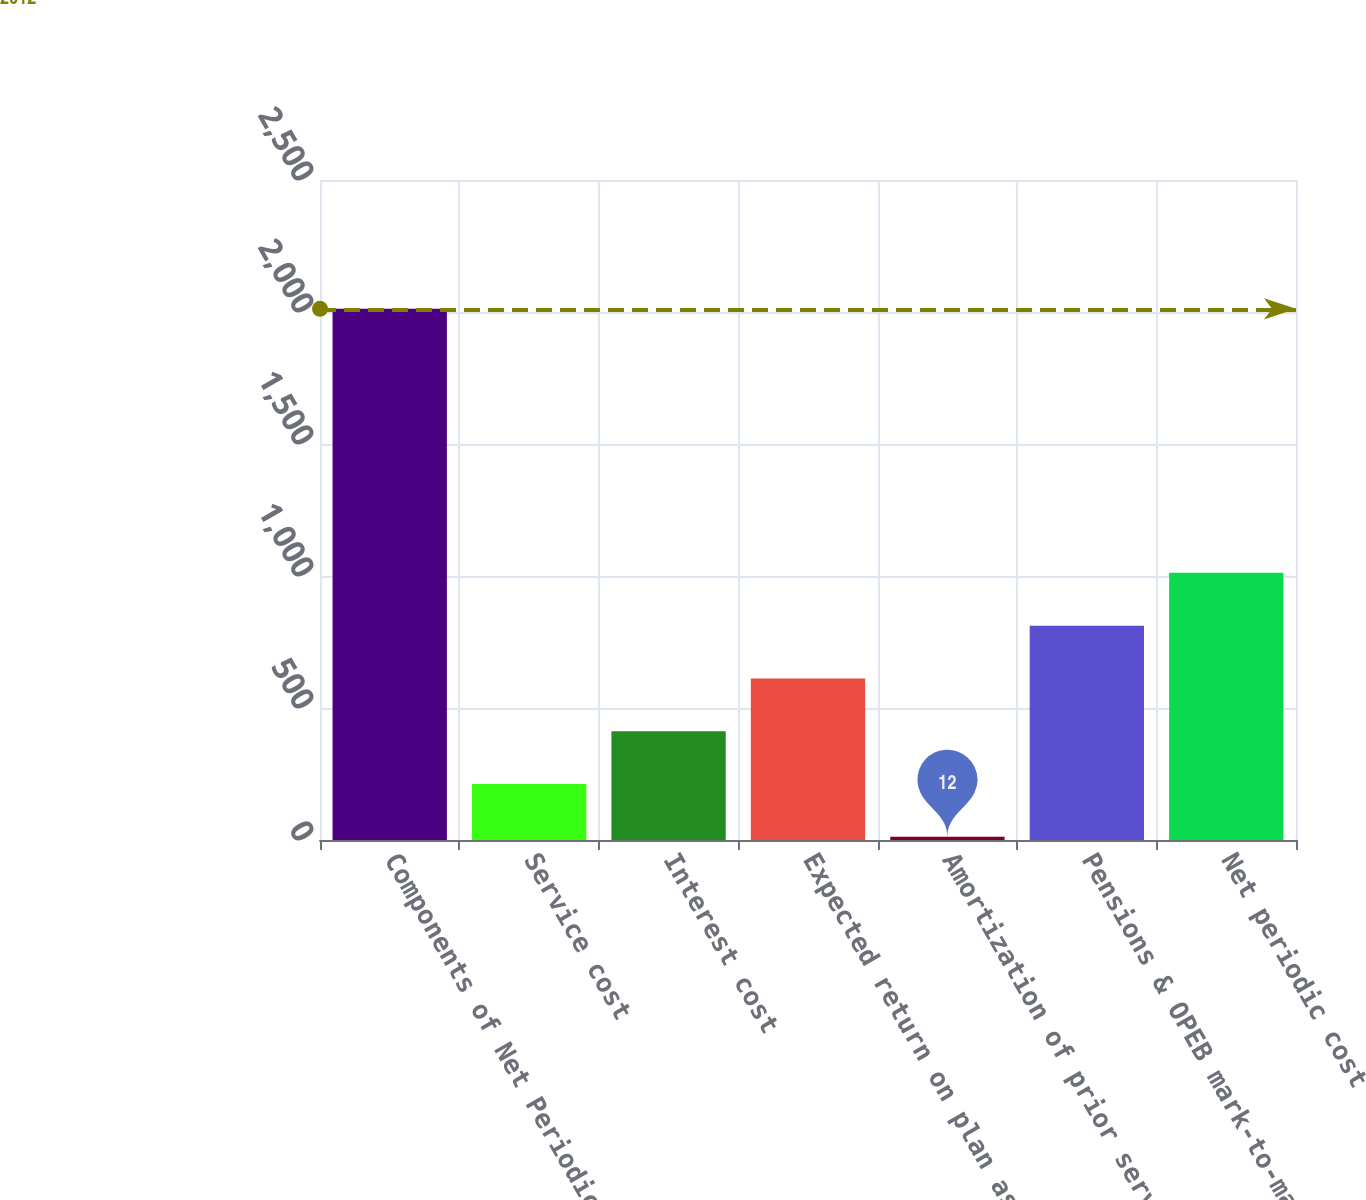Convert chart. <chart><loc_0><loc_0><loc_500><loc_500><bar_chart><fcel>Components of Net Periodic<fcel>Service cost<fcel>Interest cost<fcel>Expected return on plan assets<fcel>Amortization of prior service<fcel>Pensions & OPEB mark-to-market<fcel>Net periodic cost<nl><fcel>2012<fcel>212<fcel>412<fcel>612<fcel>12<fcel>812<fcel>1012<nl></chart> 